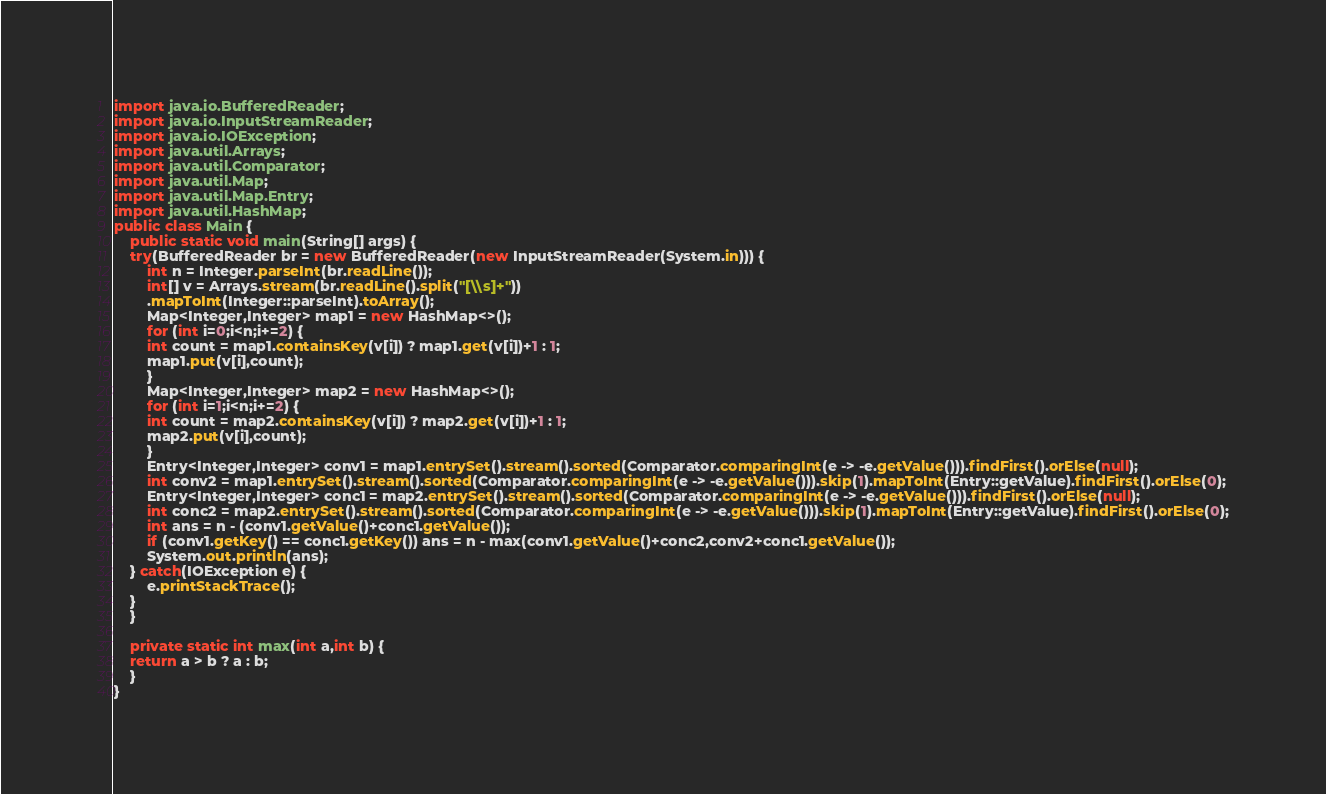Convert code to text. <code><loc_0><loc_0><loc_500><loc_500><_Java_>import java.io.BufferedReader;
import java.io.InputStreamReader;
import java.io.IOException;
import java.util.Arrays;
import java.util.Comparator;
import java.util.Map;
import java.util.Map.Entry;
import java.util.HashMap;
public class Main {
    public static void main(String[] args) {
	try(BufferedReader br = new BufferedReader(new InputStreamReader(System.in))) {
	    int n = Integer.parseInt(br.readLine());
	    int[] v = Arrays.stream(br.readLine().split("[\\s]+"))
		.mapToInt(Integer::parseInt).toArray();
	    Map<Integer,Integer> map1 = new HashMap<>();
	    for (int i=0;i<n;i+=2) {
		int count = map1.containsKey(v[i]) ? map1.get(v[i])+1 : 1;
		map1.put(v[i],count);
	    }
	    Map<Integer,Integer> map2 = new HashMap<>();
	    for (int i=1;i<n;i+=2) {
		int count = map2.containsKey(v[i]) ? map2.get(v[i])+1 : 1;
		map2.put(v[i],count);
	    }
	    Entry<Integer,Integer> conv1 = map1.entrySet().stream().sorted(Comparator.comparingInt(e -> -e.getValue())).findFirst().orElse(null);
	    int conv2 = map1.entrySet().stream().sorted(Comparator.comparingInt(e -> -e.getValue())).skip(1).mapToInt(Entry::getValue).findFirst().orElse(0);
	    Entry<Integer,Integer> conc1 = map2.entrySet().stream().sorted(Comparator.comparingInt(e -> -e.getValue())).findFirst().orElse(null);
	    int conc2 = map2.entrySet().stream().sorted(Comparator.comparingInt(e -> -e.getValue())).skip(1).mapToInt(Entry::getValue).findFirst().orElse(0);
	    int ans = n - (conv1.getValue()+conc1.getValue());
	    if (conv1.getKey() == conc1.getKey()) ans = n - max(conv1.getValue()+conc2,conv2+conc1.getValue());
	    System.out.println(ans);
	} catch(IOException e) {
	    e.printStackTrace();
	}
    }
    
    private static int max(int a,int b) {
	return a > b ? a : b;
    }
}</code> 